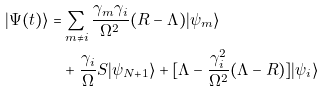<formula> <loc_0><loc_0><loc_500><loc_500>| \Psi ( t ) \rangle = & \sum _ { m \neq i } \frac { \gamma _ { m } \gamma _ { i } } { \Omega ^ { 2 } } ( R - \Lambda ) | \psi _ { m } \rangle & \\ & + \frac { \gamma _ { i } } { \Omega } S | \psi _ { N + 1 } \rangle + [ \Lambda - \frac { \gamma _ { i } ^ { 2 } } { \Omega ^ { 2 } } ( \Lambda - R ) ] | \psi _ { i } \rangle &</formula> 